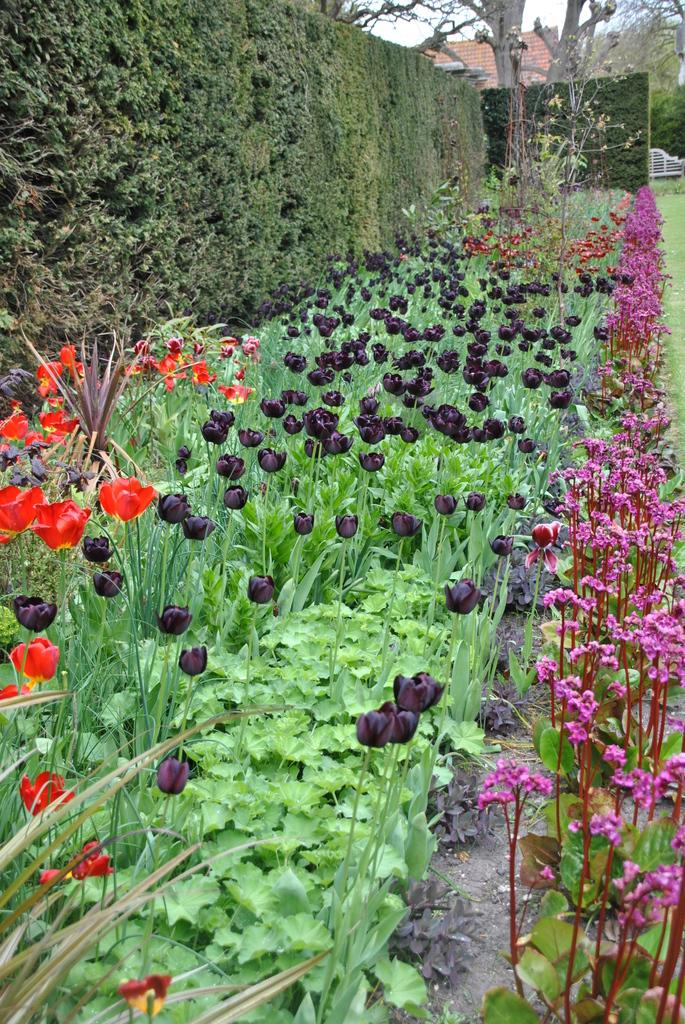What type of plants can be seen in the image? There are different color flower plants in the image. What can be seen at the top of the image? There are trees and a bench visible at the top of the image. Is there any structure visible at the top of the image? Yes, there is a house at the top of the image. What type of hall can be seen in the image? There is no hall present in the image. What kind of loss is depicted in the image? There is no loss depicted in the image; it features flower plants, trees, a bench, and a house. 